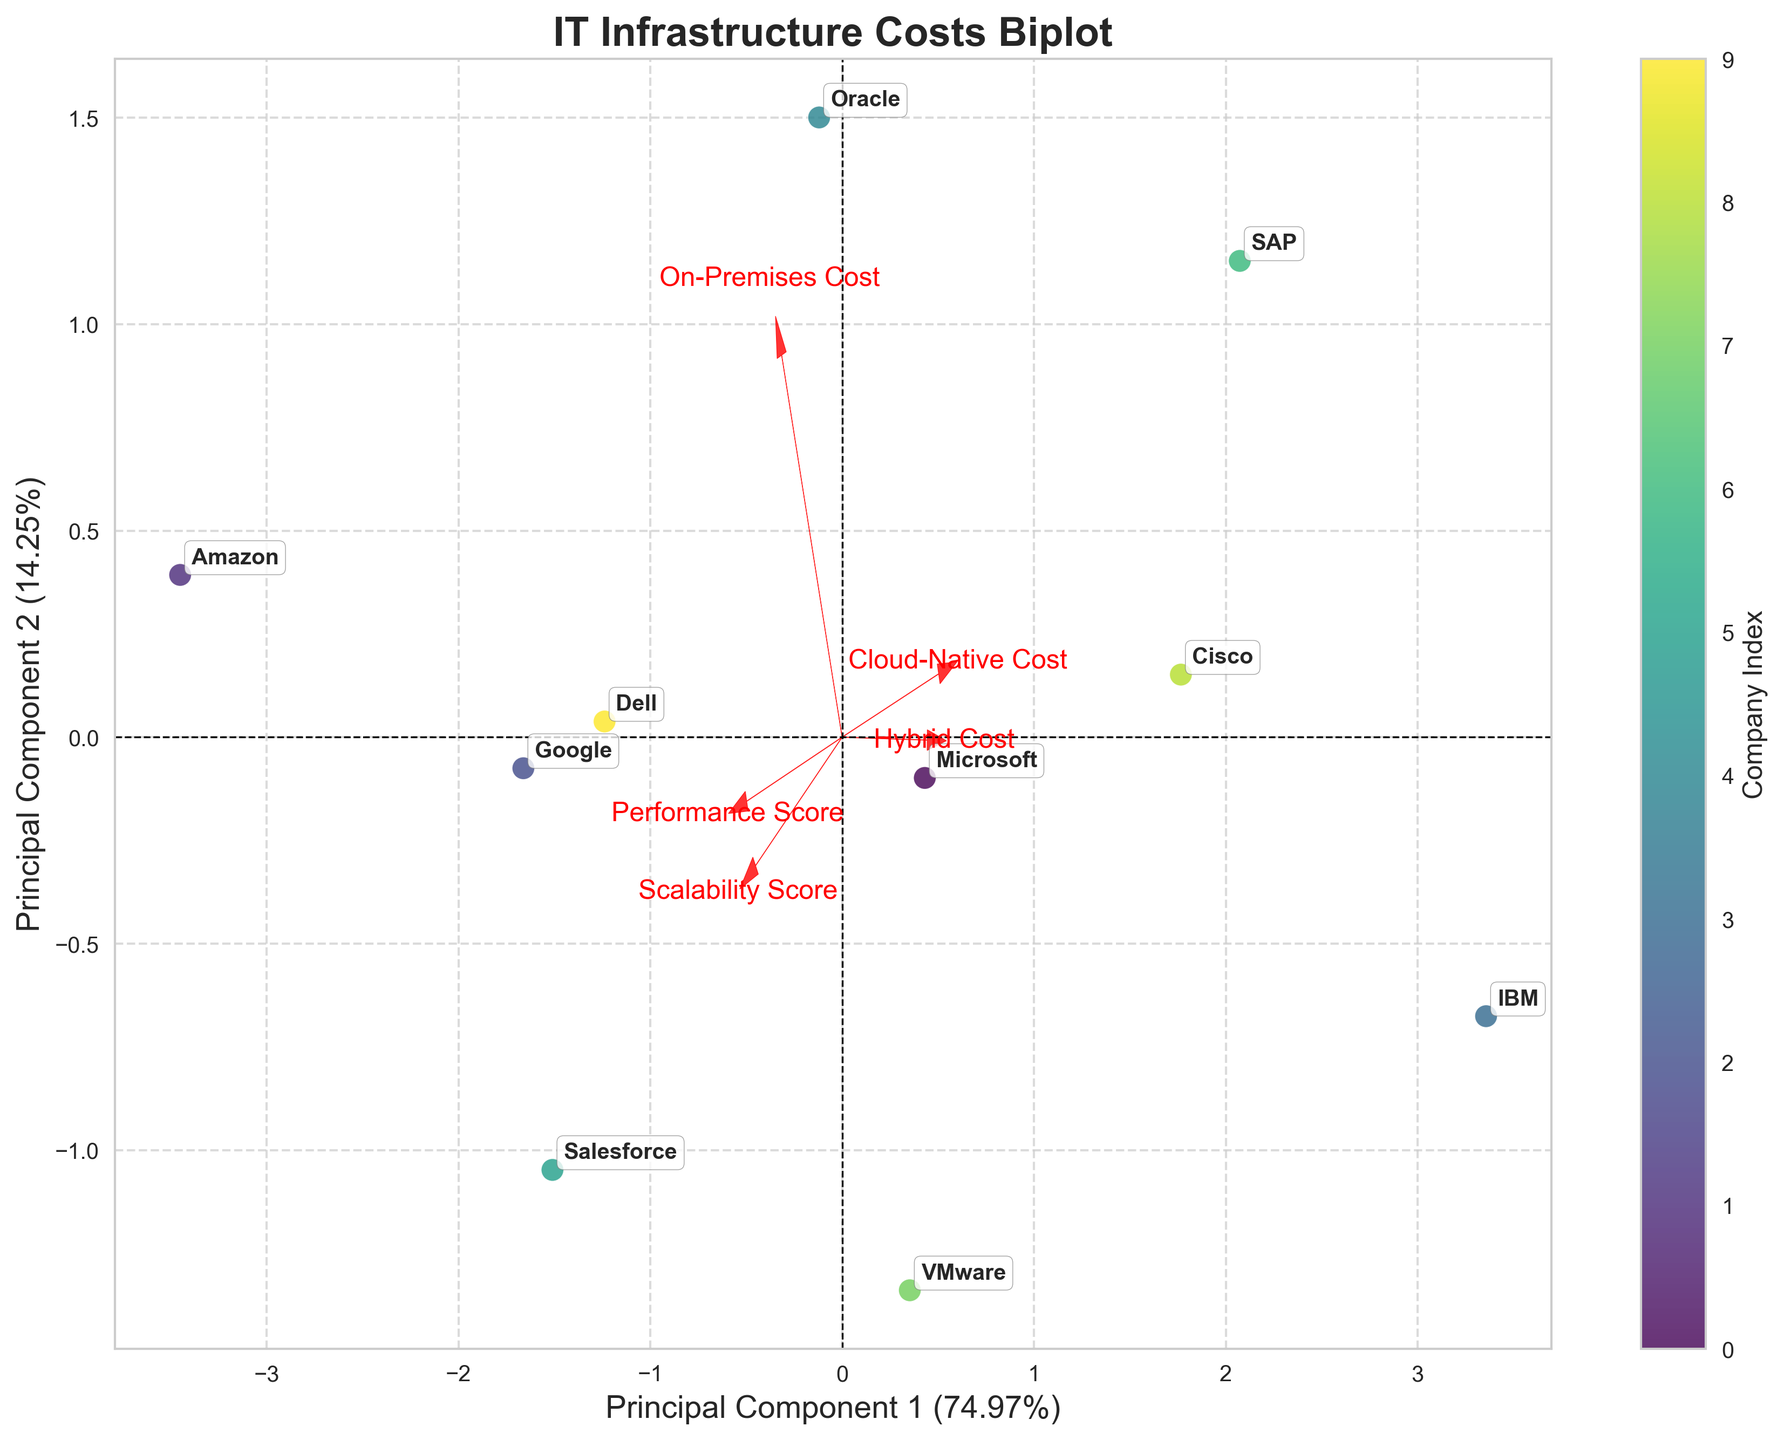What is the title of the biplot? The title of the biplot is located at the top of the plot. It reads "IT Infrastructure Costs Biplot," indicating the subject of the visualization.
Answer: IT Infrastructure Costs Biplot How many companies are represented in the biplot? Each company is labeled on the biplot. By counting the labels, you can see that there are 10 companies represented.
Answer: 10 Which company is located furthest to the right on the biplot? By examining the positions of the companies on the biplot, Amazon is located furthest to the right.
Answer: Amazon Which feature has the highest loading on Principal Component 1? The arrows representing the loadings of the features point outward from the origin. The length and direction of each arrow indicate the loading. The "On-Premises Cost" feature has the most significant loading along the Principal Component 1 axis.
Answer: On-Premises Cost What do the colors of the data points represent in this biplot? The color of each data point is associated with the 'Company Index.' A colorbar is provided that indicates this relationship.
Answer: Company Index Which company has the highest Performance Score, and where is it located on the biplot? The Performance Score has a higher arrow loading in the positive direction of Principal Component 2. Amazon, which has the highest Performance Score of 88, is located in the upper right of the biplot.
Answer: Amazon What are the Principal Component 1 and Principal Component 2 percentages? The percentages are located at the ends of the axis labels for the principal components. The label for Principal Component 1 is about 37% and for Principal Component 2, it is approximately 27%.
Answer: Principal Component 1: ~37%, Principal Component 2: ~27% Which two features are most similar based on their loadings? By observing the direction and length of the arrows (loadings) for the features, the "Performance Score" and "Scalability Score" are most similar since their arrows point in almost the same direction.
Answer: Performance Score and Scalability Score Which company is positioned closest to the origin, and what might this indicate? Examining the positions of the companies relative to the origin, Salesforce is positioned closest. This position likely indicates that Salesforce's costs and performance metrics are close to the average values.
Answer: Salesforce Which cost category contributes least to Principal Component 2? By looking at the direction and magnitude of the arrows for each cost category, the "On-Premises Cost" has minimal loading on Principal Component 2 since its arrow points primarily along Principal Component 1.
Answer: On-Premises Cost 